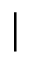Convert formula to latex. <formula><loc_0><loc_0><loc_500><loc_500>|</formula> 